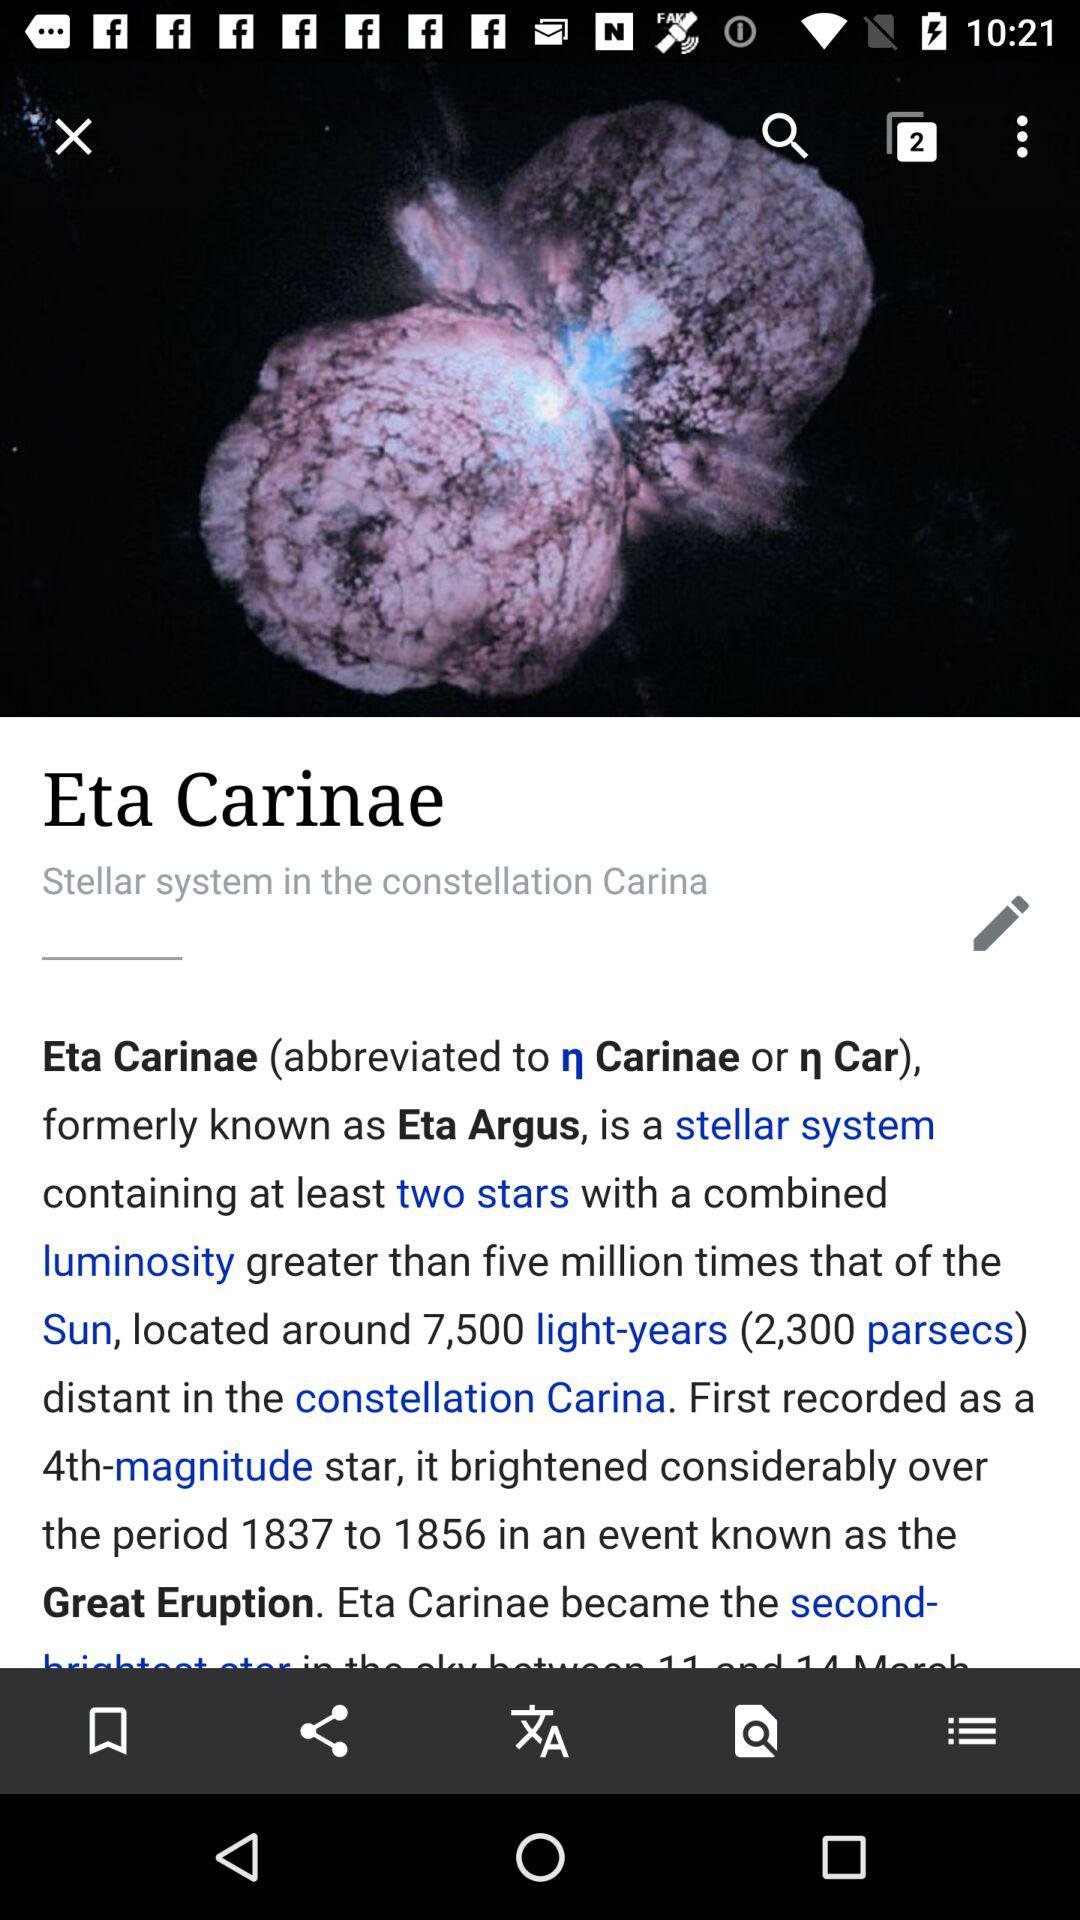How many stars does a stellar system contain? A stellar system consists of two stars. 